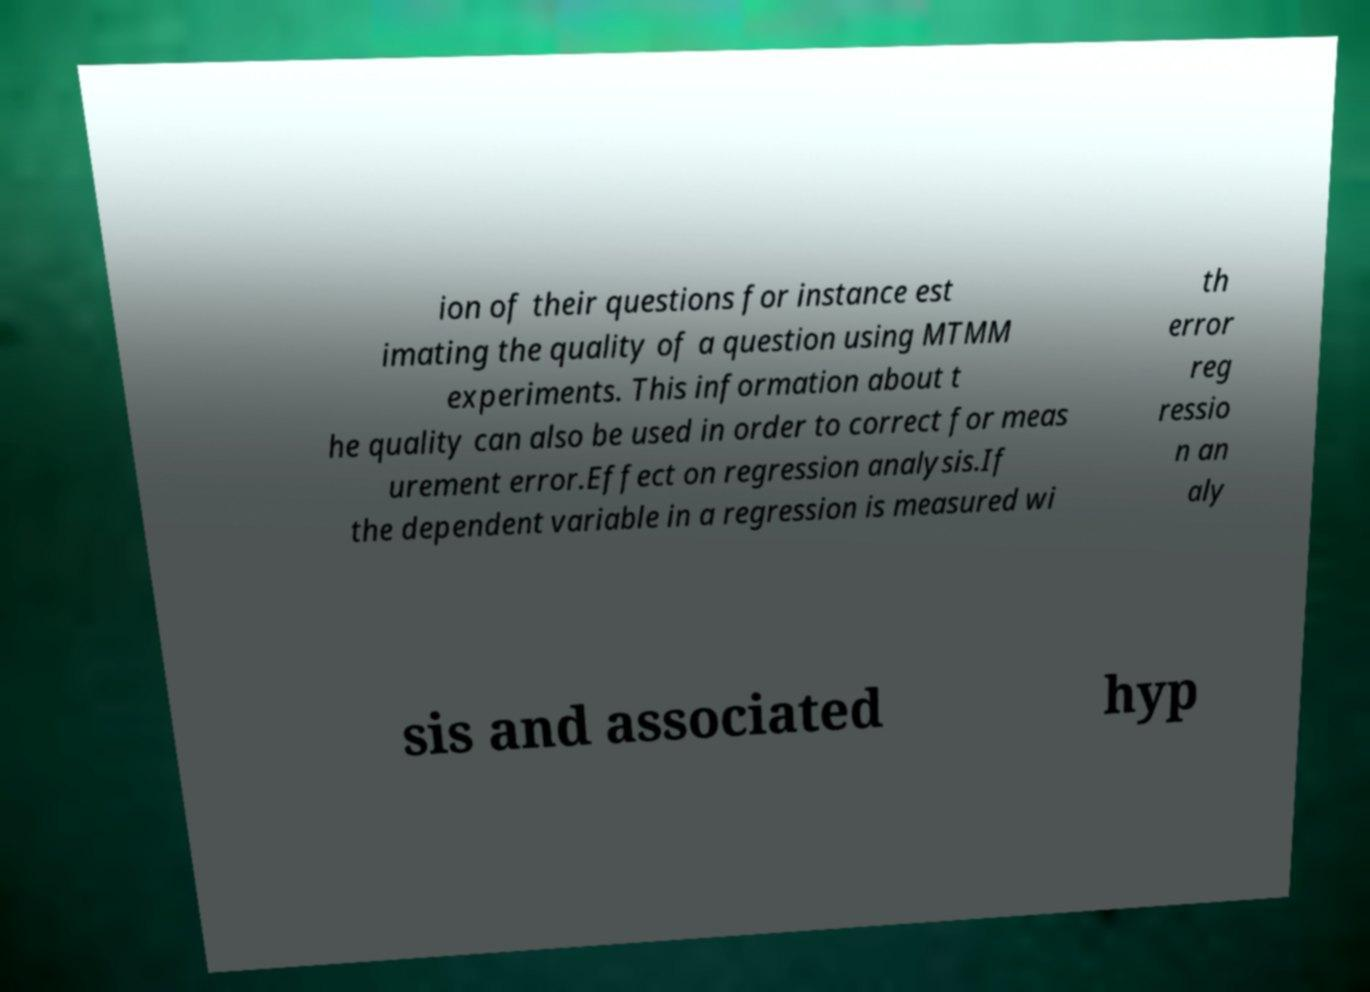Can you accurately transcribe the text from the provided image for me? ion of their questions for instance est imating the quality of a question using MTMM experiments. This information about t he quality can also be used in order to correct for meas urement error.Effect on regression analysis.If the dependent variable in a regression is measured wi th error reg ressio n an aly sis and associated hyp 